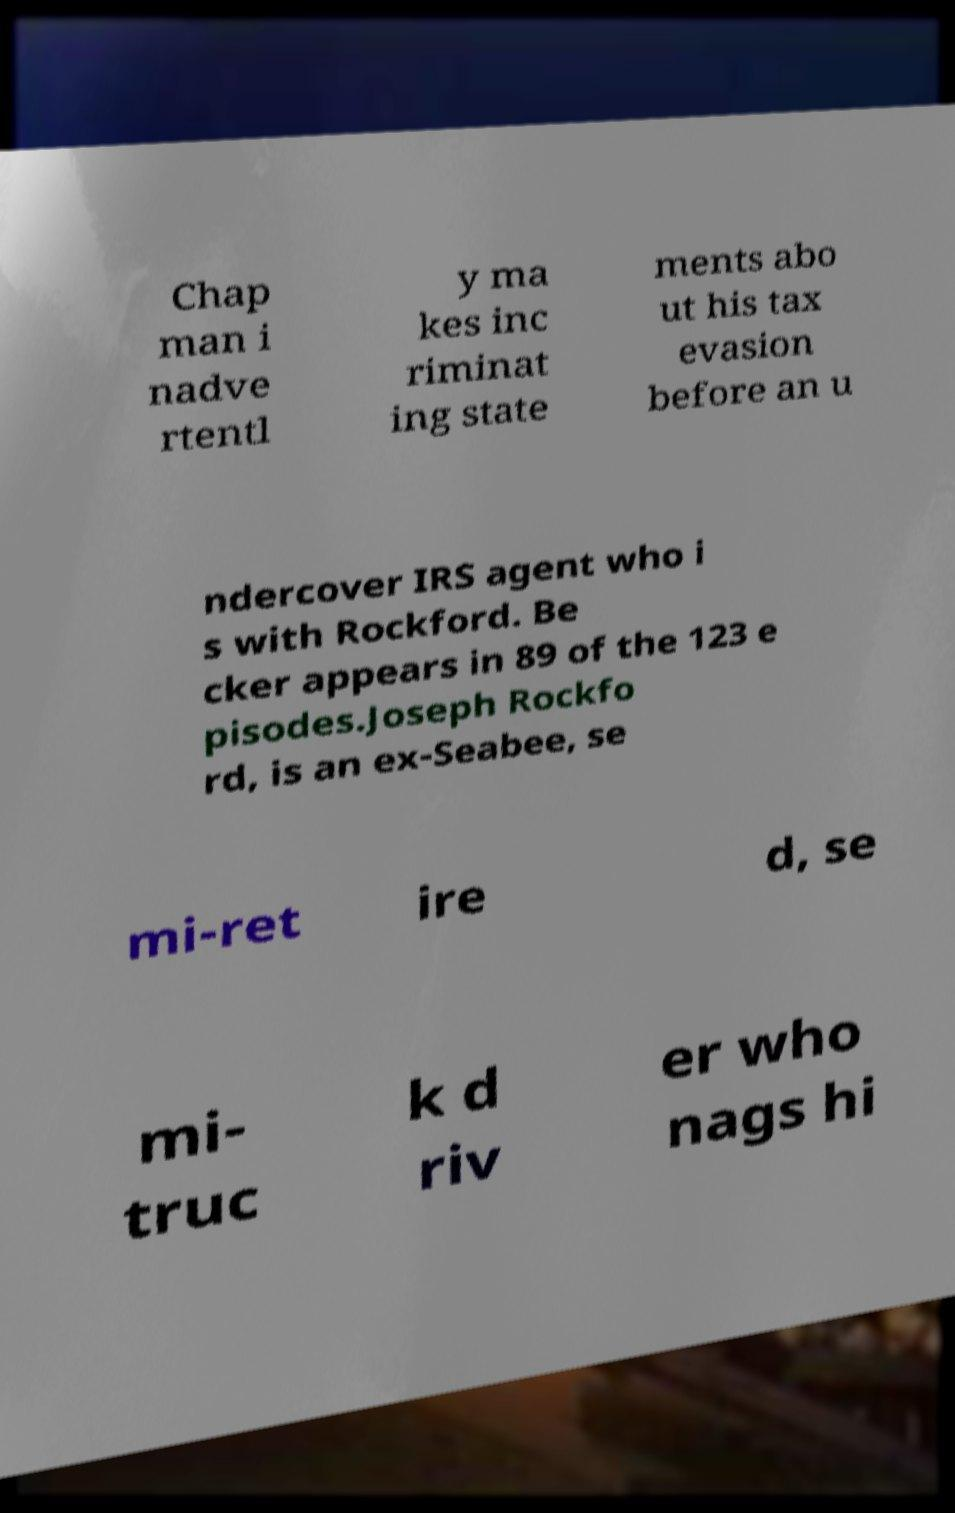For documentation purposes, I need the text within this image transcribed. Could you provide that? Chap man i nadve rtentl y ma kes inc riminat ing state ments abo ut his tax evasion before an u ndercover IRS agent who i s with Rockford. Be cker appears in 89 of the 123 e pisodes.Joseph Rockfo rd, is an ex-Seabee, se mi-ret ire d, se mi- truc k d riv er who nags hi 